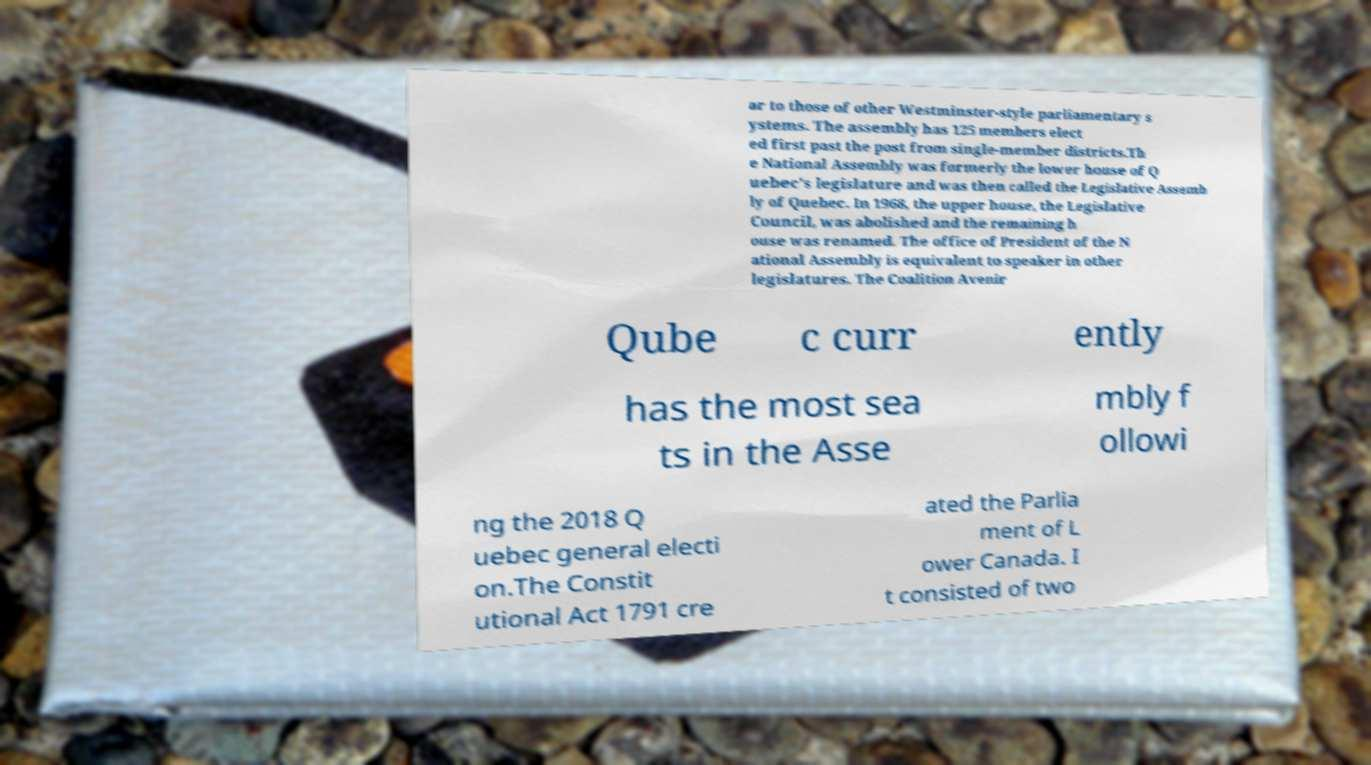I need the written content from this picture converted into text. Can you do that? ar to those of other Westminster-style parliamentary s ystems. The assembly has 125 members elect ed first past the post from single-member districts.Th e National Assembly was formerly the lower house of Q uebec's legislature and was then called the Legislative Assemb ly of Quebec. In 1968, the upper house, the Legislative Council, was abolished and the remaining h ouse was renamed. The office of President of the N ational Assembly is equivalent to speaker in other legislatures. The Coalition Avenir Qube c curr ently has the most sea ts in the Asse mbly f ollowi ng the 2018 Q uebec general electi on.The Constit utional Act 1791 cre ated the Parlia ment of L ower Canada. I t consisted of two 